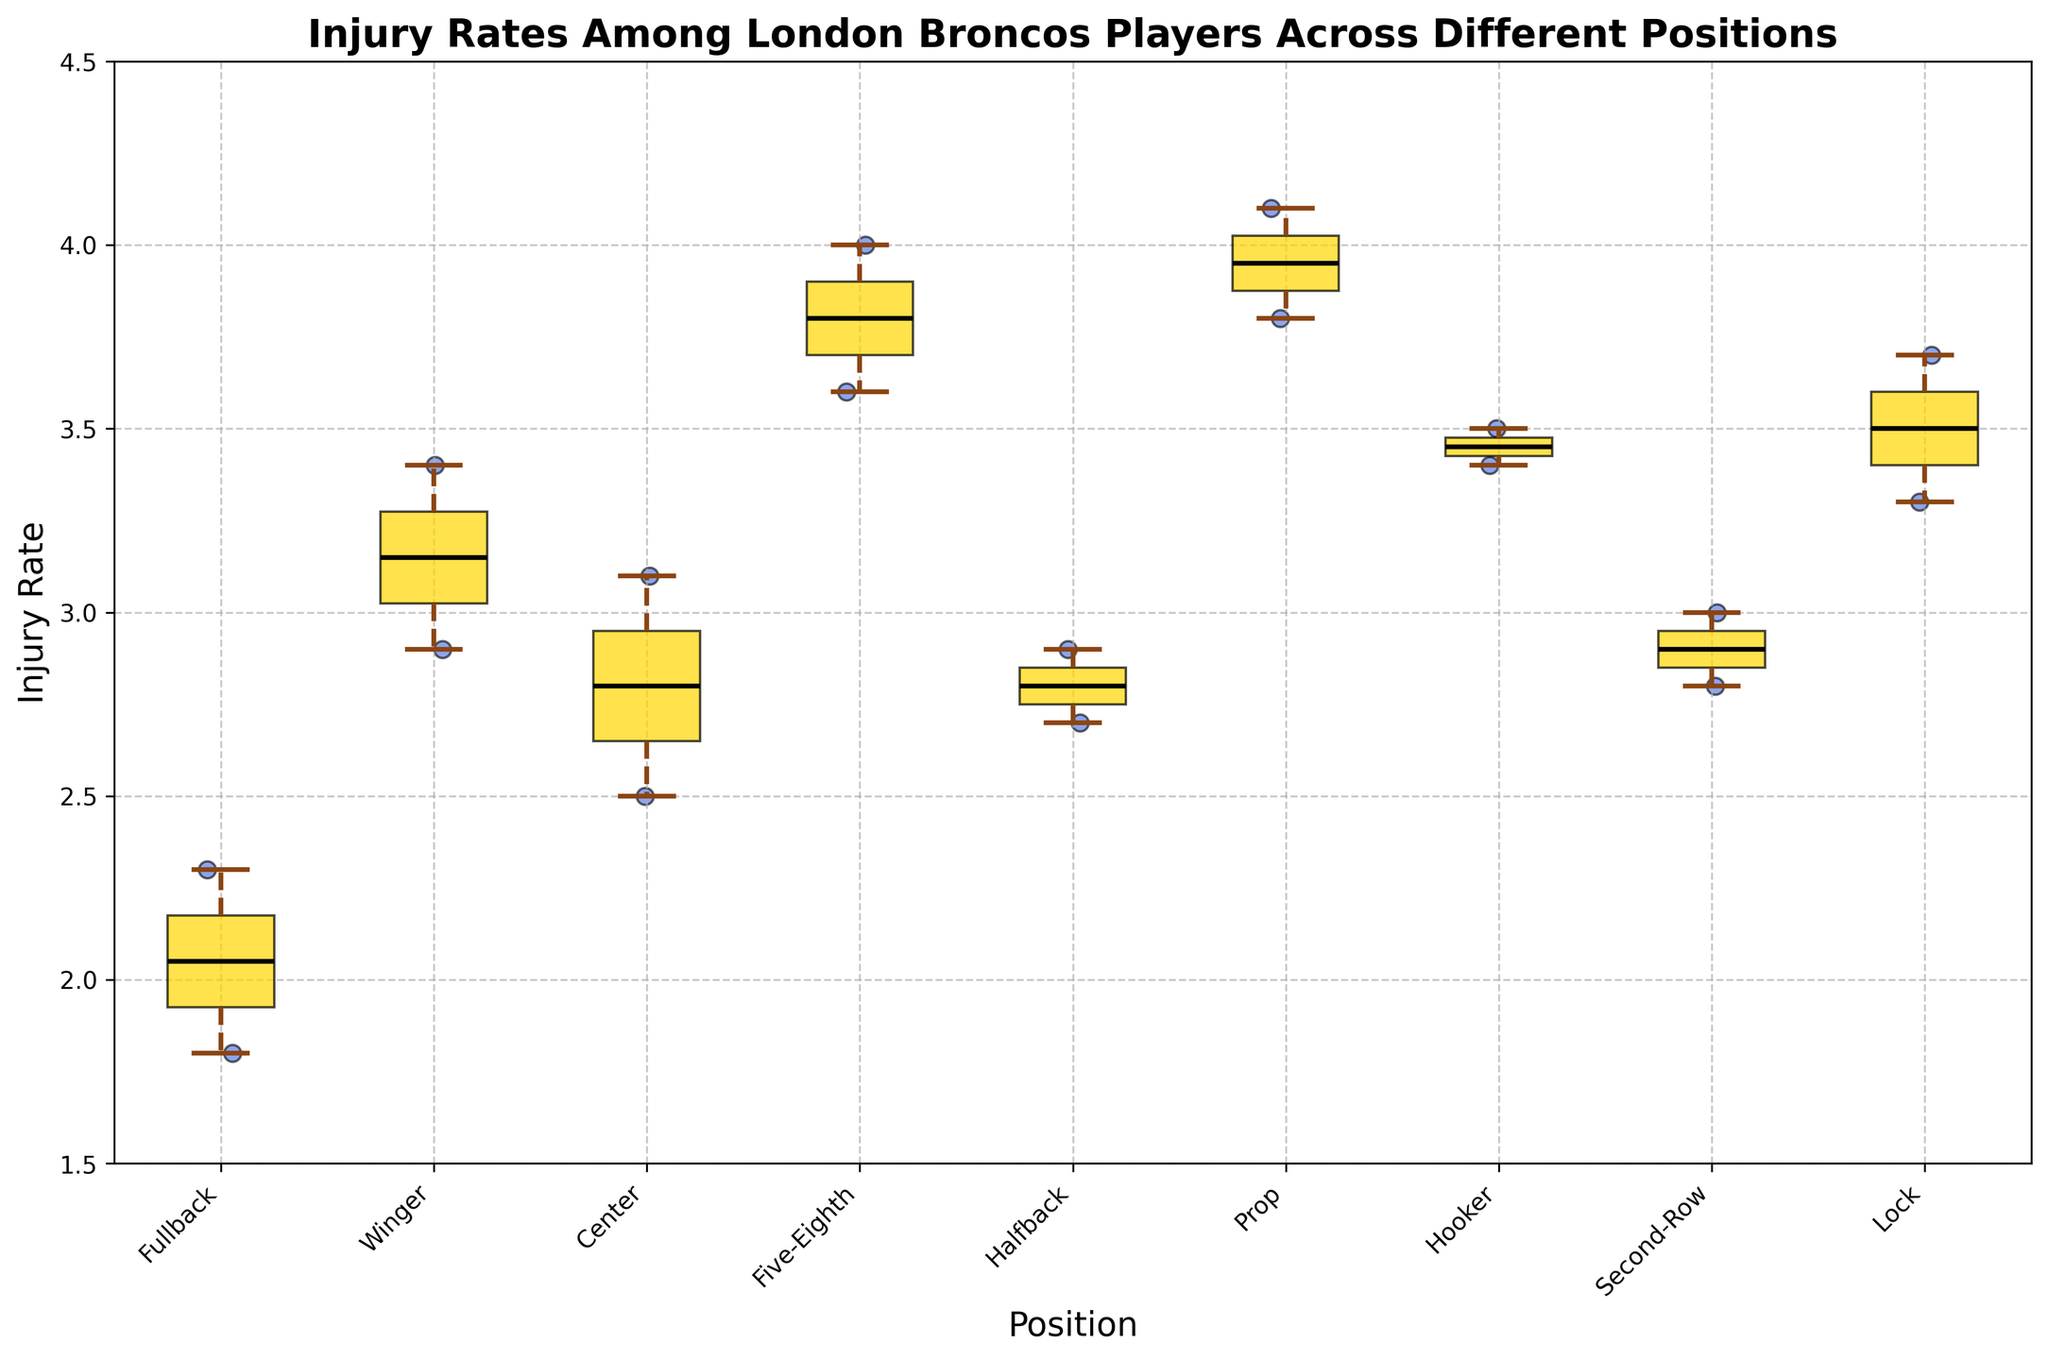What's the title of the figure? The title is located at the top and states the main focus of the figure.
Answer: Injury Rates Among London Broncos Players Across Different Positions What is the color of the box plots? The visual shows the boxes with a distinct color, which in this case, is a shade of yellow.
Answer: Yellow Which position has the highest median injury rate? To find this, identify the middle line within each box plot and see which is positioned highest on the y-axis.
Answer: Five-Eighth Which player has the lowest injury rate and what position do they play? Look for the scatter point at the lowest y-value, then trace back to the corresponding position. The lowest point is 1.8, which belongs to Olly Ashall-Bott (Fullback).
Answer: Olly Ashall-Bott, Fullback How do the injury rates of Fullback players compare to those of Five-Eighth players? Compare the position and spread of the box plots and scatter points for these two positions. Fullbacks have lower and less spread injury rates compared to Five-Eighth players which have higher rates and a wider spread.
Answer: Fullbacks have lower and less spread injury rates Which position has the greatest spread in injury rates? The position with the largest range between the smallest and largest scatter points indicates the greatest spread. The wider the box and whiskers, the greater the spread.
Answer: Prop What is the difference between the maximum injury rate of Prop players and Lock players? Identify the highest points in the scatter plots for Prop and Lock players, which are 4.1 and 3.7 respectively and then subtract.
Answer: 0.4 Which position's box plot has the greatest interquartile range (IQR)? Look for the box plot with the tallest box, indicating the widest range between the first and third quartiles.
Answer: Five-Eighth Are there any positions without any outliers? Outliers are typically the scatter points outside the whiskers. Check each position's scatter points and whether any fall beyond the whisker range.
Answer: No, all positions have outliers Which positions have median injury rates above 3.0? Examine each box plot to see if the median (middle line in the box) is above the 3.0 injury rate mark.
Answer: Five-Eighth, Prop, Hooker, Lock 